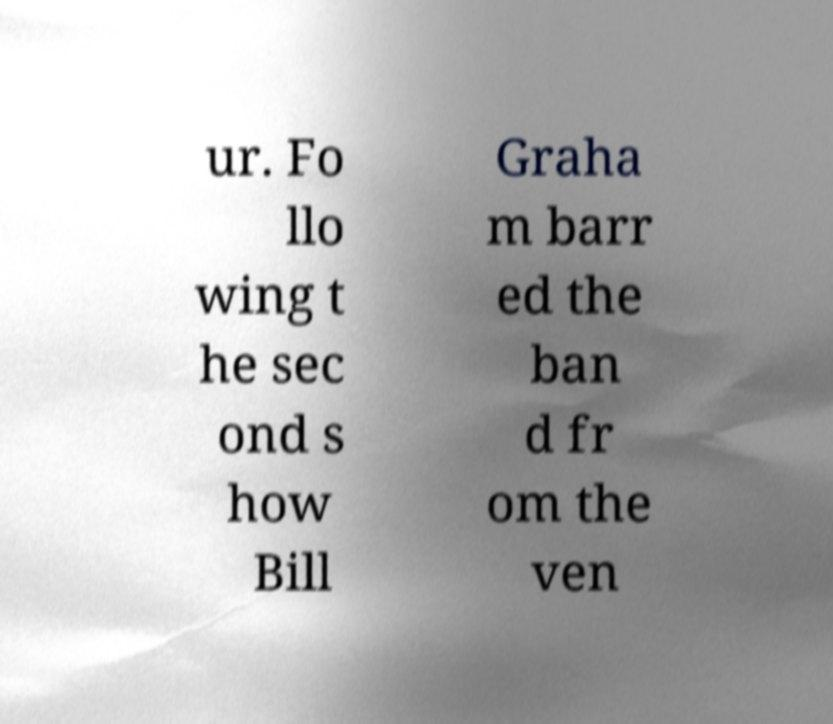I need the written content from this picture converted into text. Can you do that? ur. Fo llo wing t he sec ond s how Bill Graha m barr ed the ban d fr om the ven 